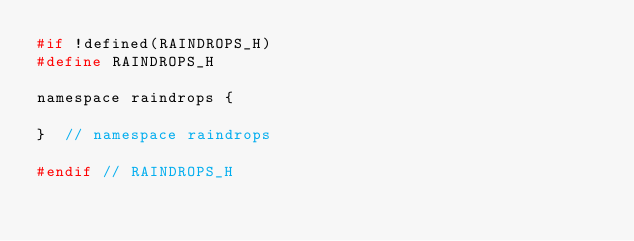<code> <loc_0><loc_0><loc_500><loc_500><_C_>#if !defined(RAINDROPS_H)
#define RAINDROPS_H

namespace raindrops {

}  // namespace raindrops

#endif // RAINDROPS_H</code> 